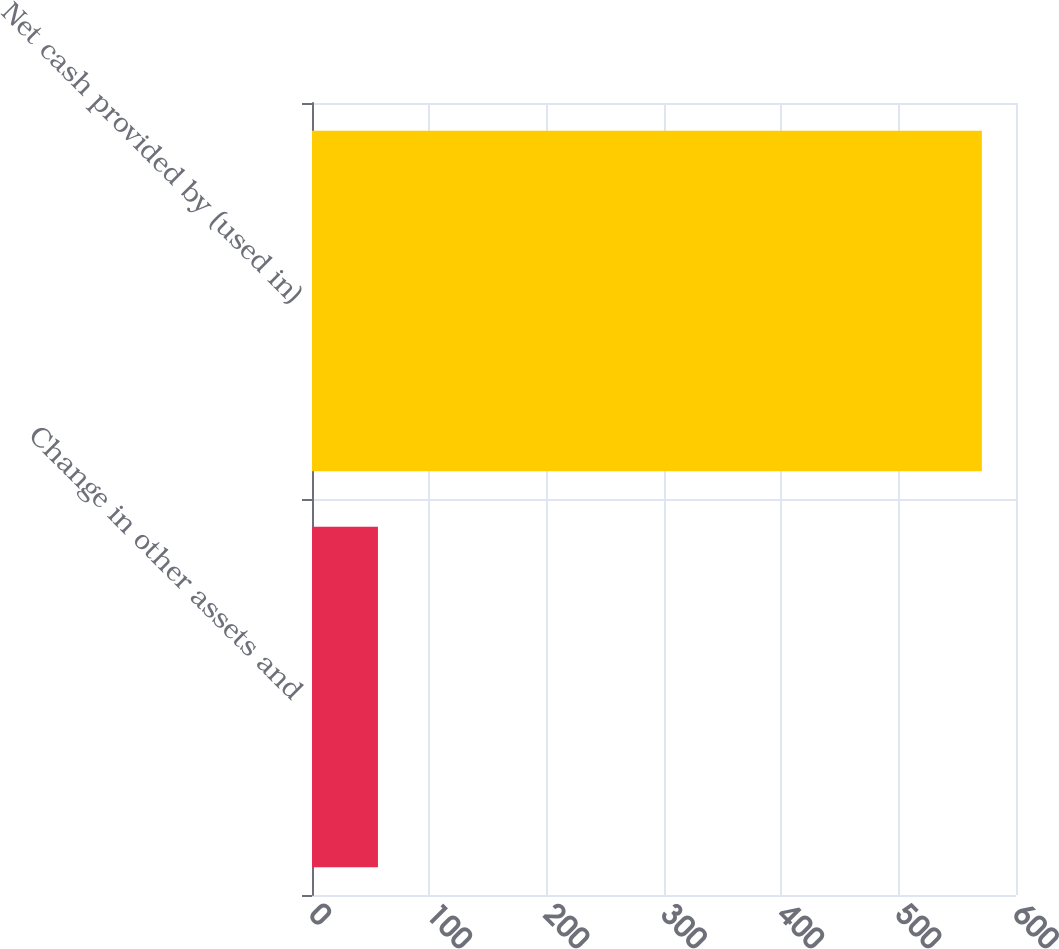Convert chart to OTSL. <chart><loc_0><loc_0><loc_500><loc_500><bar_chart><fcel>Change in other assets and<fcel>Net cash provided by (used in)<nl><fcel>56.2<fcel>570.9<nl></chart> 